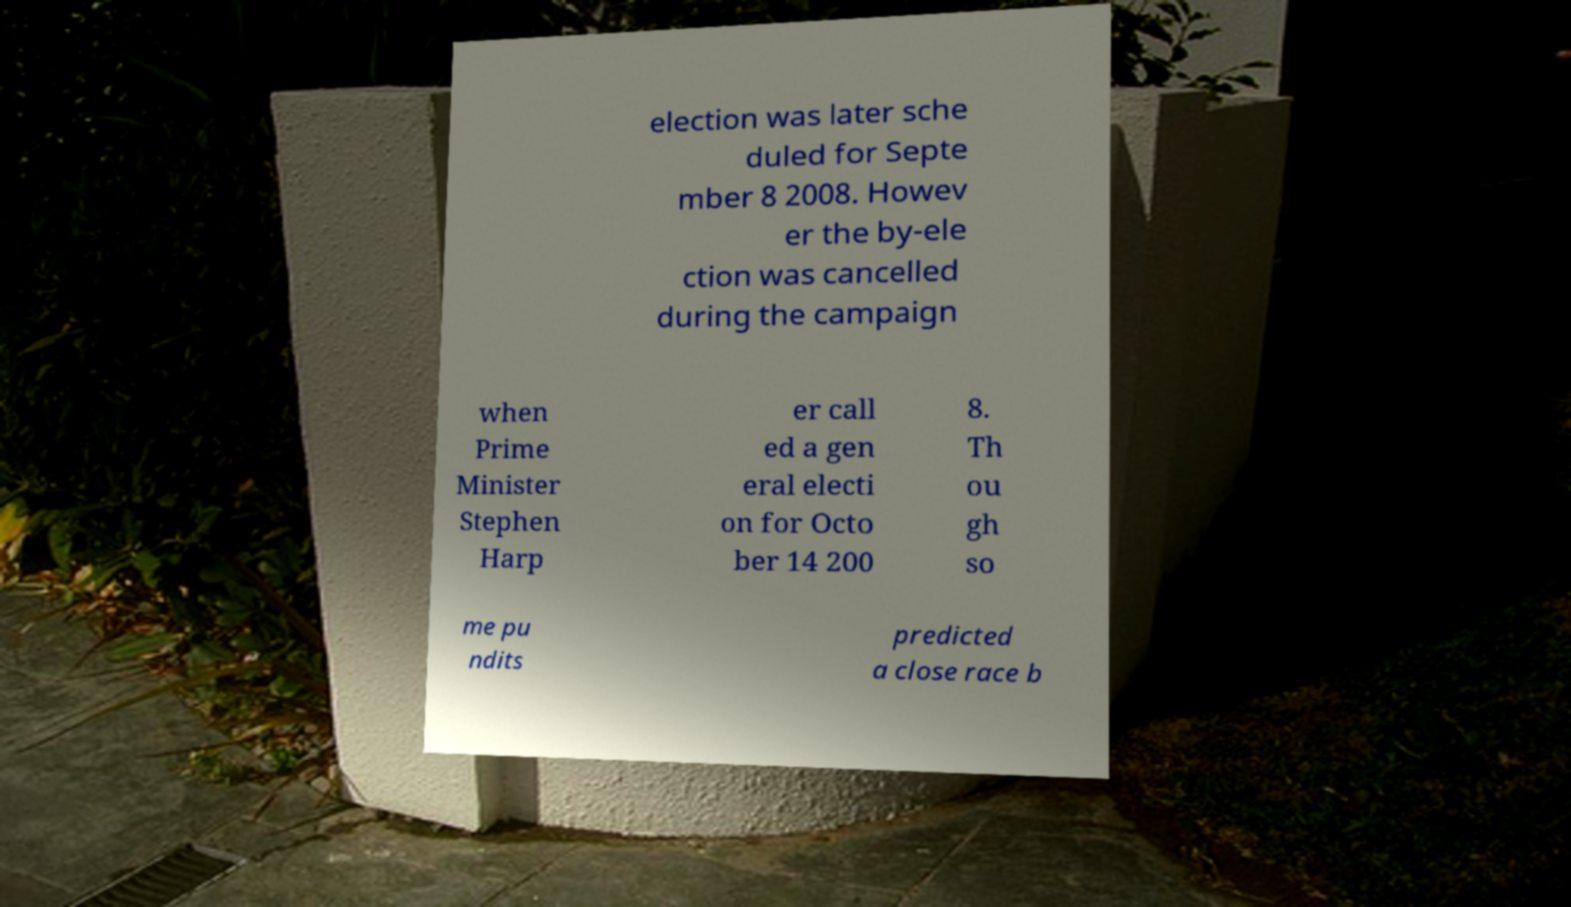There's text embedded in this image that I need extracted. Can you transcribe it verbatim? election was later sche duled for Septe mber 8 2008. Howev er the by-ele ction was cancelled during the campaign when Prime Minister Stephen Harp er call ed a gen eral electi on for Octo ber 14 200 8. Th ou gh so me pu ndits predicted a close race b 